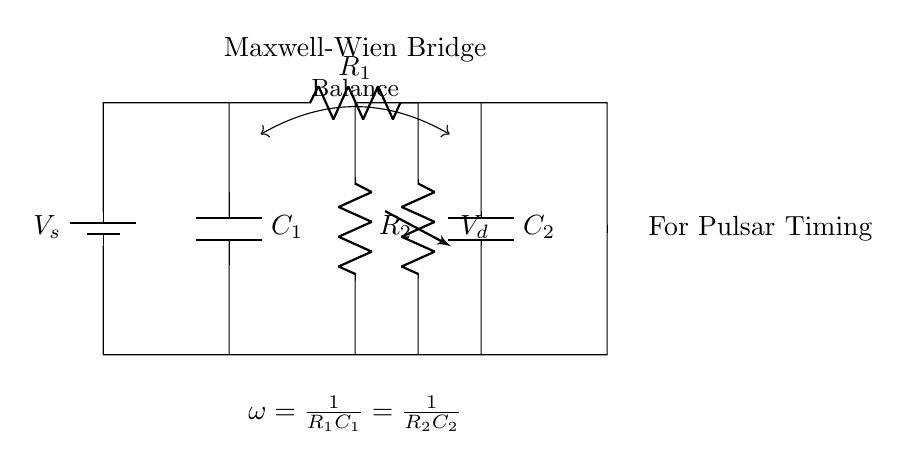What is the purpose of the Maxwell-Wien bridge? The purpose is to measure resistance with high precision, making it ideal for applications like pulsar timing.
Answer: High precision measurement What is the voltage source in this circuit? The voltage source is labeled as V_s, which is the supply voltage in the circuit.
Answer: V_s What are the two capacitors in the circuit? The two capacitors are labeled as C_1 and C_2, located at the left and right sections of the circuit, respectively.
Answer: C_1 and C_2 What must be true for the bridge to be balanced? The condition for balance is that the angular frequency must satisfy the equation omega equals one over R_1C_1 equals one over R_2C_2.
Answer: omega equals one over R_1C_1 equals one over R_2C_2 What is the role of the resistors in this circuit? The resistors R_1 and R_2 are used to set the conditions for balance in the bridge, impacting the measurement precision.
Answer: To set balance conditions What is the significance of the labeled output voltage V_d? The output voltage V_d indicates the voltage difference that is measured to determine if the bridge is balanced.
Answer: It indicates the bridge balance measurement What type of circuit is represented in this diagram? The diagram represents a Maxwell-Wien bridge circuit, which is used in precision resistance measurement.
Answer: Maxwell-Wien bridge 